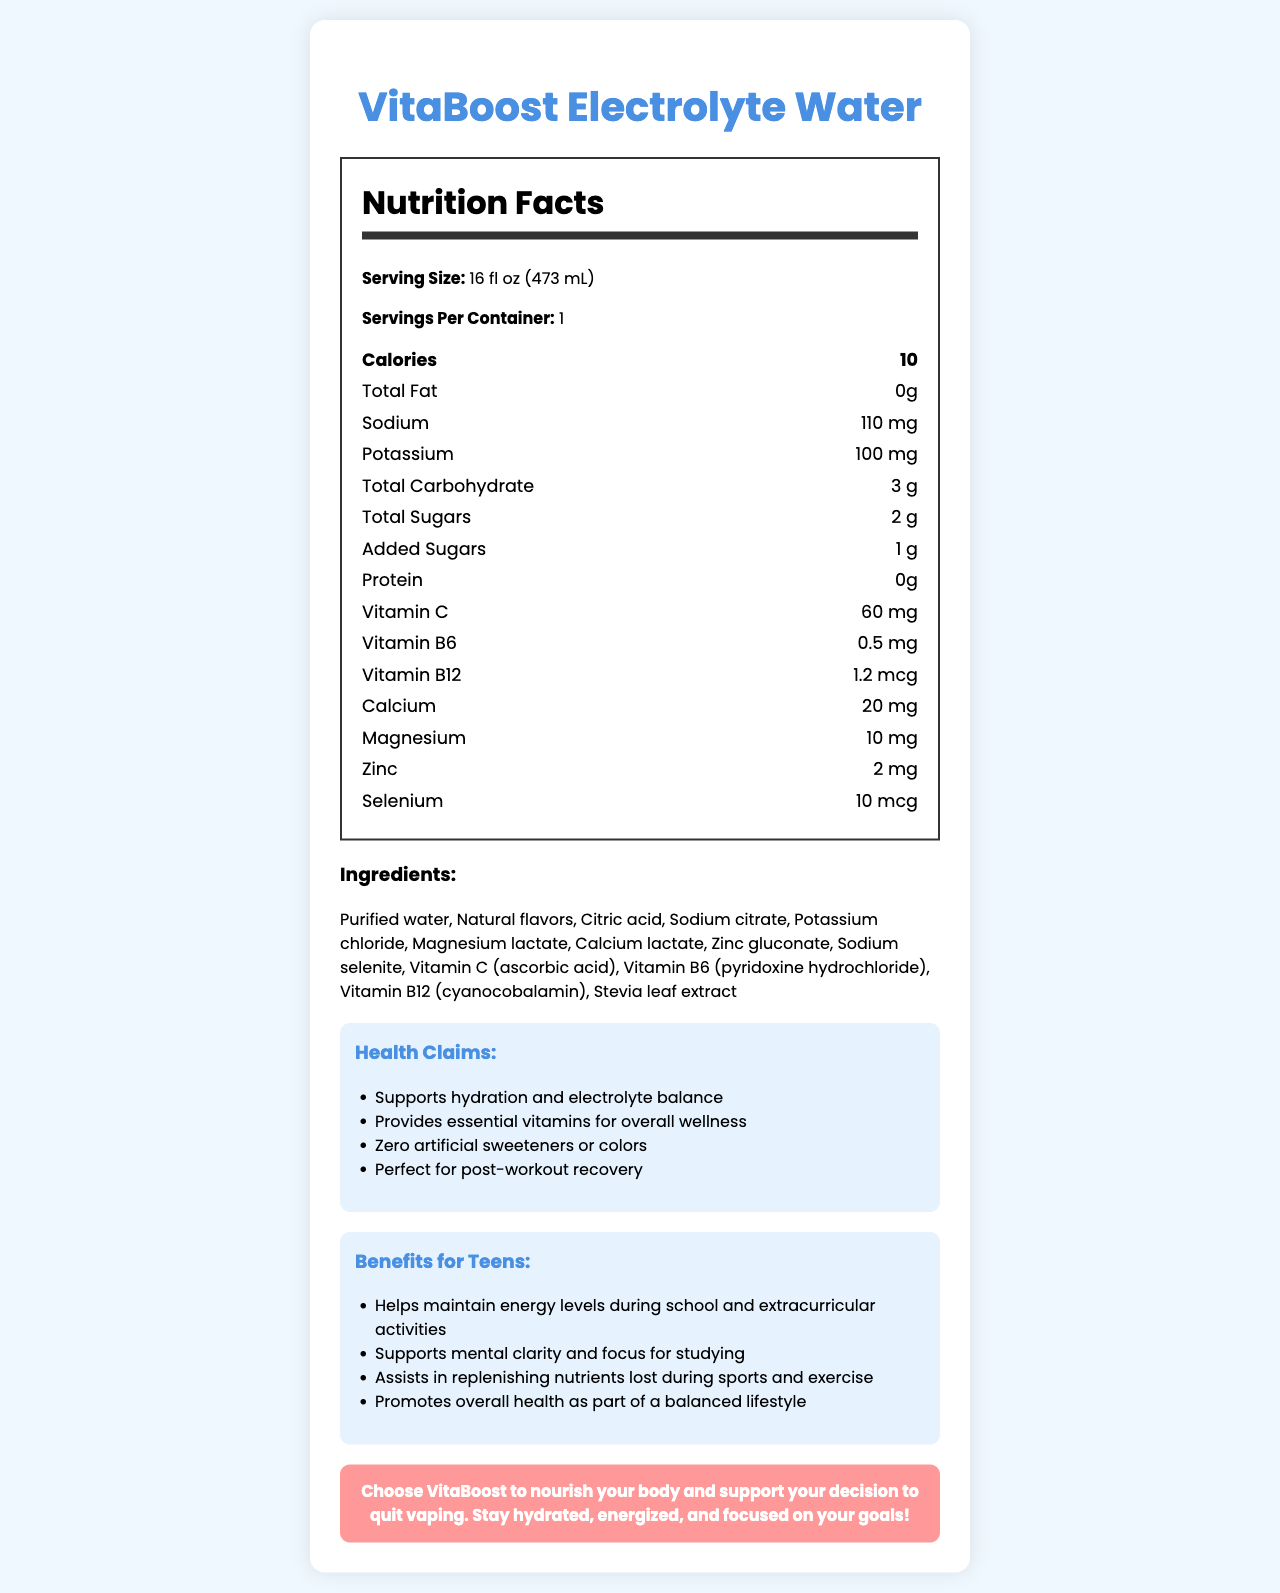what is the serving size? The serving size is explicitly mentioned at the beginning of the Nutrition Facts section.
Answer: 16 fl oz (473 mL) How many servings are in one container? The document states "Servings Per Container: 1".
Answer: 1 How many calories are there per serving? In the Nutrition Facts section, it clearly states "Calories: 10".
Answer: 10 calories What is the amount of sodium in a serving? The sodium content is listed as "Sodium: 110 mg".
Answer: 110 mg How much protein is in the product? The protein content is given as "Protein: 0 g".
Answer: 0 g Which vitamin is present in the highest amount in this water? Vitamin C is listed as having 60 mg, which is higher compared to the other vitamins and minerals.
Answer: Vitamin C What are two benefits of this product for teenagers? These benefits are listed under the "Benefits for Teens" section.
Answer: Helps maintain energy levels during school and extracurricular activities, Supports mental clarity and focus for studying What is the total amount of sugars in a serving? The total sugar content is "Total Sugars: 2 g".
Answer: 2 g What ingredient provides the sweetness in the product? This ingredient is listed as one of the components in the "Ingredients" section.
Answer: Stevia leaf extract How is this product marketed as a healthier alternative to vaping? A. It contains nicotine B. It supports hydration and electrolyte balance C. It is an energy drink The marketing message emphasizes choosing VitaBoost to nourish your body, which includes statements about hydration and electrolyte balance.
Answer: B Which of the following is not a health claim made by the product? I. Supports hydration and electrolyte balance II. Provides essential vitamins for overall wellness III. Contains natural caffeine for energy The health claims listed do not mention caffeine; the correct health claims are I and II.
Answer: III Is this product marketed as containing artificial sweeteners or colors? One of the health claims specifically states "Zero artificial sweeteners or colors".
Answer: No Summarize the main points of the document. The document contains multiple sections including nutrition facts, ingredients, health claims, teen benefits, and a specific message for those quitting vaping, emphasizing the overall health benefits and absence of artificial additives.
Answer: The document is a nutrition facts label for VitaBoost Electrolyte Water, which details its vitamin and mineral content, ingredients, health claims, and benefits for teens. It highlights the product's role in hydration, providing essential nutrients, and supporting an active lifestyle, particularly targeting adolescents. A special note mentions it as a good alternative for those quitting vaping. What is the daily value percentage of any nutrient? The document does not provide the daily value percentages for the listed nutrients, only the amount in milligrams or grams.
Answer: Not enough information 